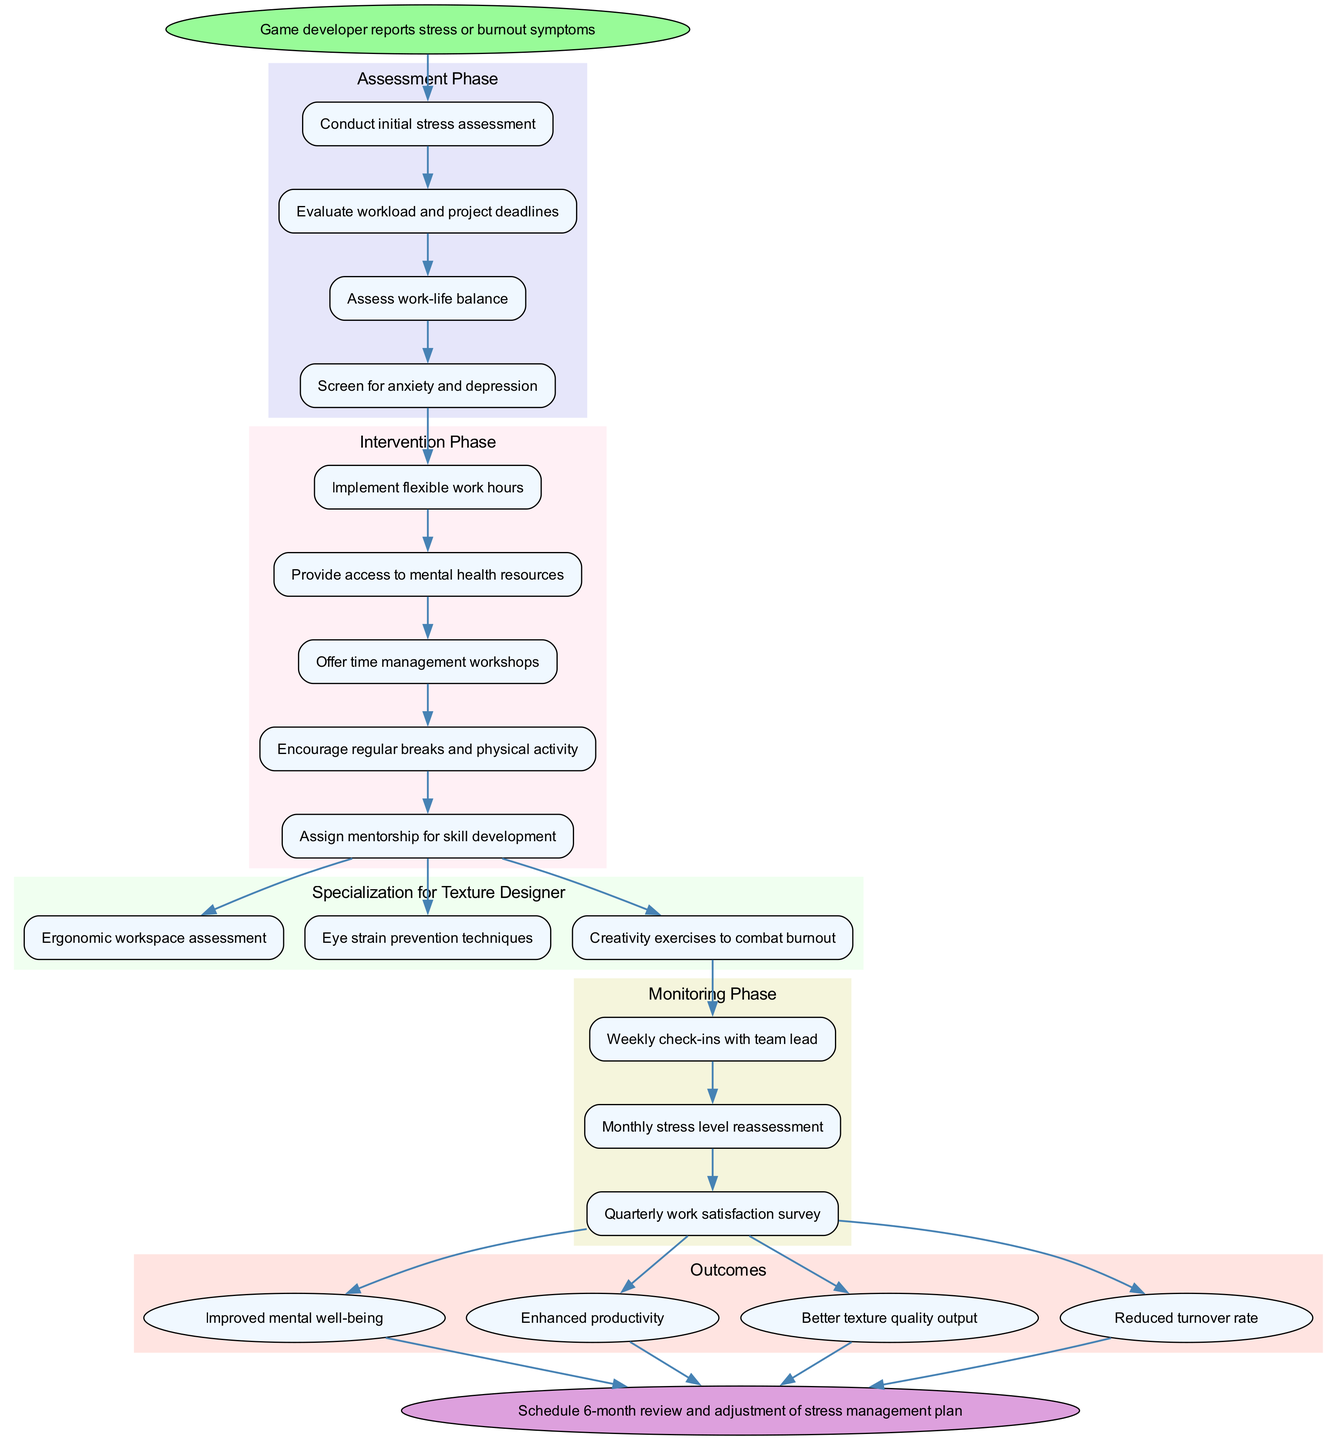What is the starting point of the clinical pathway? The starting point is indicated as "Game developer reports stress or burnout symptoms," which is the first node in the diagram.
Answer: Game developer reports stress or burnout symptoms How many steps are in the Assessment Phase? The Assessment Phase consists of four steps, each indicated by a separate node in the diagram, which can be counted by observing the cluster dedicated to this phase.
Answer: 4 What is the first intervention implemented after the assessment phase? The first intervention is "Implement flexible work hours," which is the first node in the Intervention Phase, directly connected to the last assessment step.
Answer: Implement flexible work hours Which nodes are linked to the Specialization for Texture Designer? The Specialization for Texture Designer phase includes three nodes, and all of them are connected to the last intervention step in the Intervention Phase, indicating this relationship.
Answer: Ergonomic workspace assessment, Eye strain prevention techniques, Creativity exercises to combat burnout What are the outcomes expected from this clinical pathway? The diagram shows four outcomes, and these are categorized within the Outcomes section. Each outcome node is directly connected to the last monitoring step.
Answer: Improved mental well-being, Enhanced productivity, Better texture quality output, Reduced turnover rate How does the monitoring phase begin in relation to the previous phases? The monitoring phase starts with the first check-in labeled as "Weekly check-ins with team lead," and is preceded by the specialization phase, which means the flow transitions from the last specialization node to the first monitoring node.
Answer: Weekly check-ins with team lead What is the purpose of the follow-up node in the clinical pathway? The follow-up node, "Schedule 6-month review and adjustment of stress management plan," is connected to all outcome nodes, indicating it serves a purpose to evaluate and adjust the overall strategy based on outcomes achieved.
Answer: Schedule 6-month review and adjustment of stress management plan What step is assessed monthly during the Monitoring Phase? The second step in the Monitoring Phase is titled "Monthly stress level reassessment," which indicates that this is specifically evaluated twice a month.
Answer: Monthly stress level reassessment What is the overall goal of the clinical pathway for managing stress and burnout? The outcomes listed collectively indicate the overarching goal of improved mental well-being and reduced turnover, emphasizing the positive impact on individual developers and the industry.
Answer: Improved mental well-being, Enhanced productivity, Better texture quality output, Reduced turnover rate 